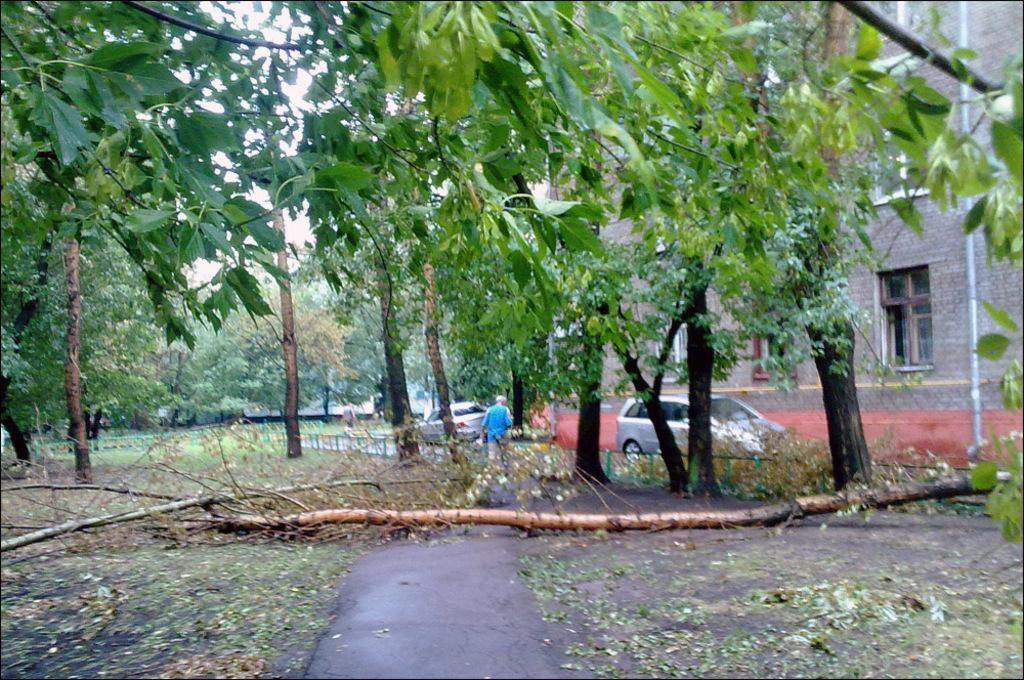Can you describe this image briefly? In this picture we can see some huge trees in the image. Behind we can see a car is parked in front of the brown house. In the front bottom side we can see the ground area. 